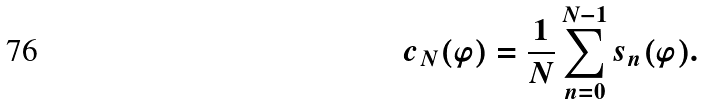Convert formula to latex. <formula><loc_0><loc_0><loc_500><loc_500>c _ { N } ( \varphi ) = \frac { 1 } { N } \sum _ { n = 0 } ^ { N - 1 } s _ { n } ( \varphi ) .</formula> 